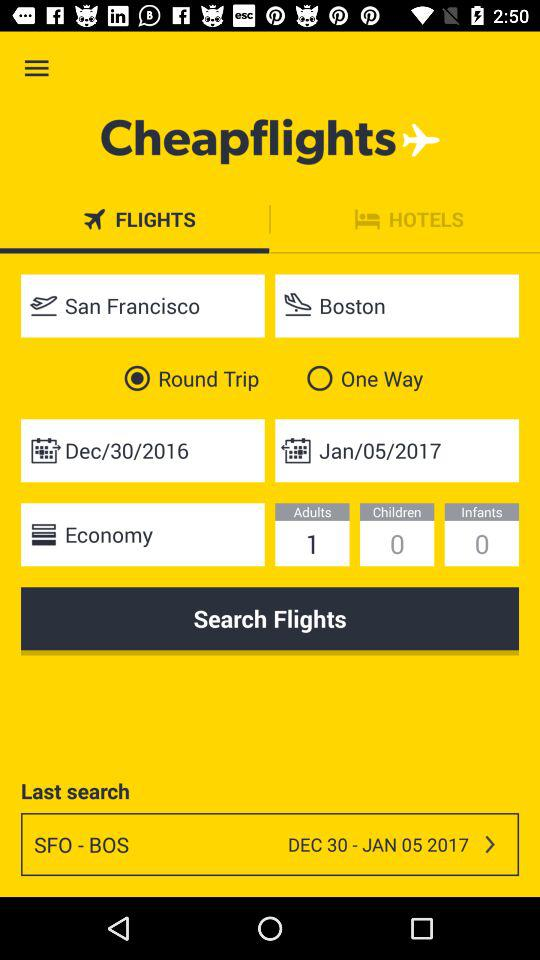What is the return date of travel? The return date of travel is January 5, 2017. 